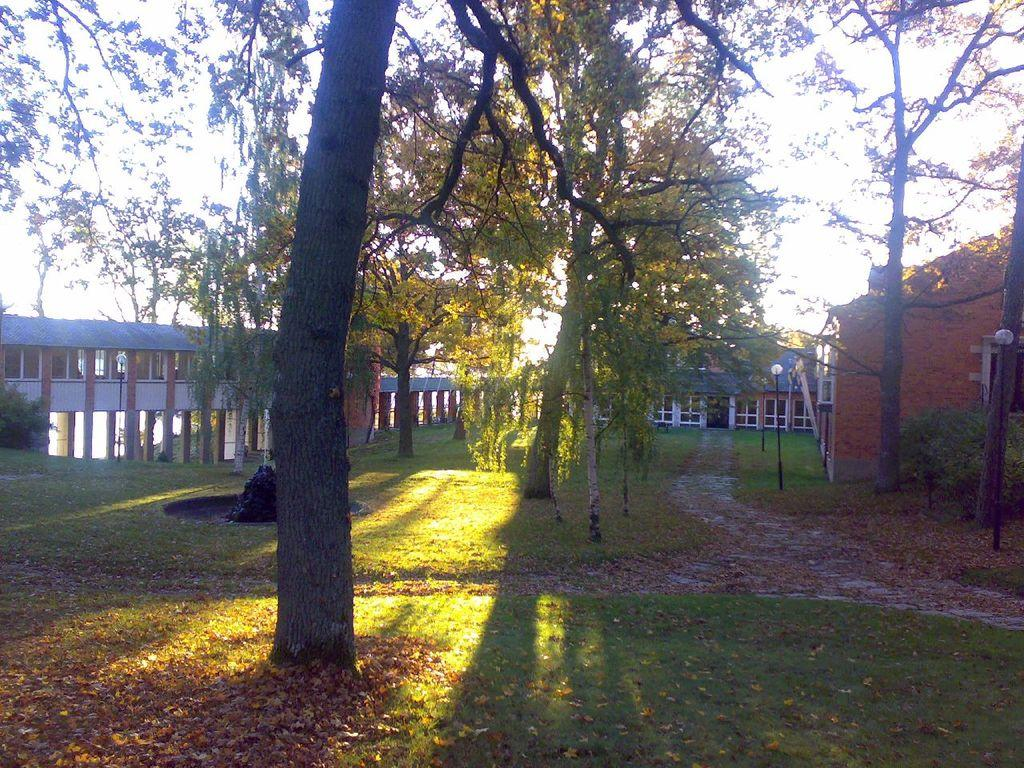What type of vegetation can be seen in the image? There are trees in the image. What structures are present to provide illumination in the image? There are light poles in the image. What type of man-made structures are visible in the background of the image? There are buildings in the background of the image. What part of the natural environment is visible in the image? The sky is visible in the background of the image. What type of vase is placed on the lamp in the image? There is no vase or lamp present in the image. How does the horn contribute to the overall aesthetic of the image? There is no horn present in the image. 